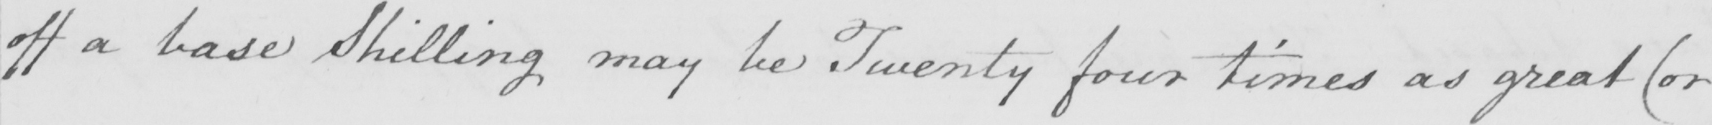Transcribe the text shown in this historical manuscript line. off a base Shilling may be Twenty four times as great  ( or 